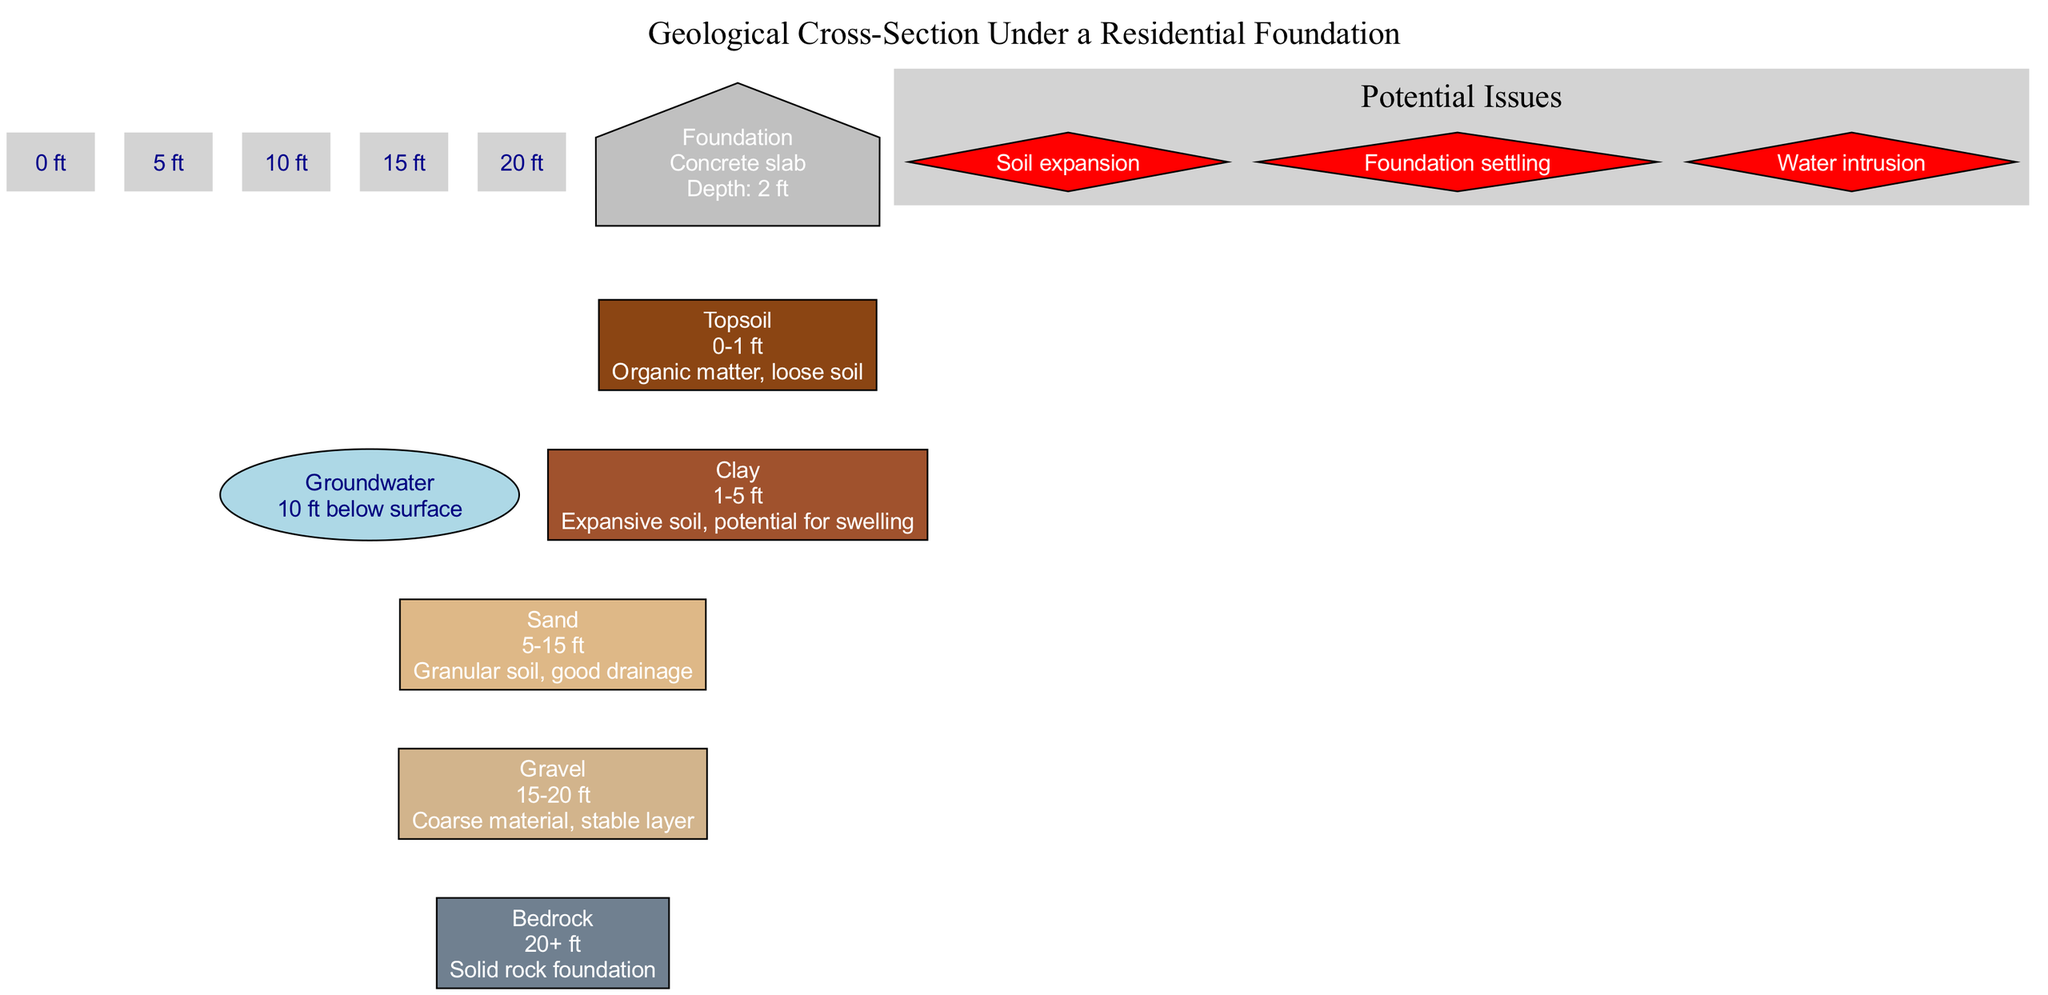What is the depth range of the clay layer? The clay layer in the diagram is described as having a depth range of 1 to 5 feet.
Answer: 1-5 ft How many types of soil layers are shown in the diagram? The diagram contains five types of soil layers: topsoil, clay, sand, gravel, and bedrock. Counting these gives us a total of five layers.
Answer: 5 What layer is immediately above the bedrock? According to the diagram, the layer immediately above the bedrock is gravel, which is at a depth of 15 to 20 feet.
Answer: Gravel What potential issue is related to the clay layer? The potential issue related to the clay layer is soil expansion, which can occur due to the expansive nature of clay.
Answer: Soil expansion What is the level of groundwater in relation to the surface? The diagram indicates that the groundwater level is located 10 feet below the surface, providing a point of reference for the soil layers above it.
Answer: 10 ft How deep is the concrete slab foundation? The diagram specifies that the depth of the concrete slab foundation is 2 feet.
Answer: 2 ft What type of foundation is used in this diagram? According to the information provided in the diagram, the foundation type is a concrete slab.
Answer: Concrete slab How does the drainage capacity of sand compare to clay? The sand layer is described as having good drainage, while the clay layer is noted for its potential for swelling, which implies poorer drainage.
Answer: Sand has good drainage; clay has poor drainage Which layer offers the most stability for the foundation? The layer that offers the most stability for the foundation is bedrock, as it is indicated as a solid rock foundation.
Answer: Bedrock 